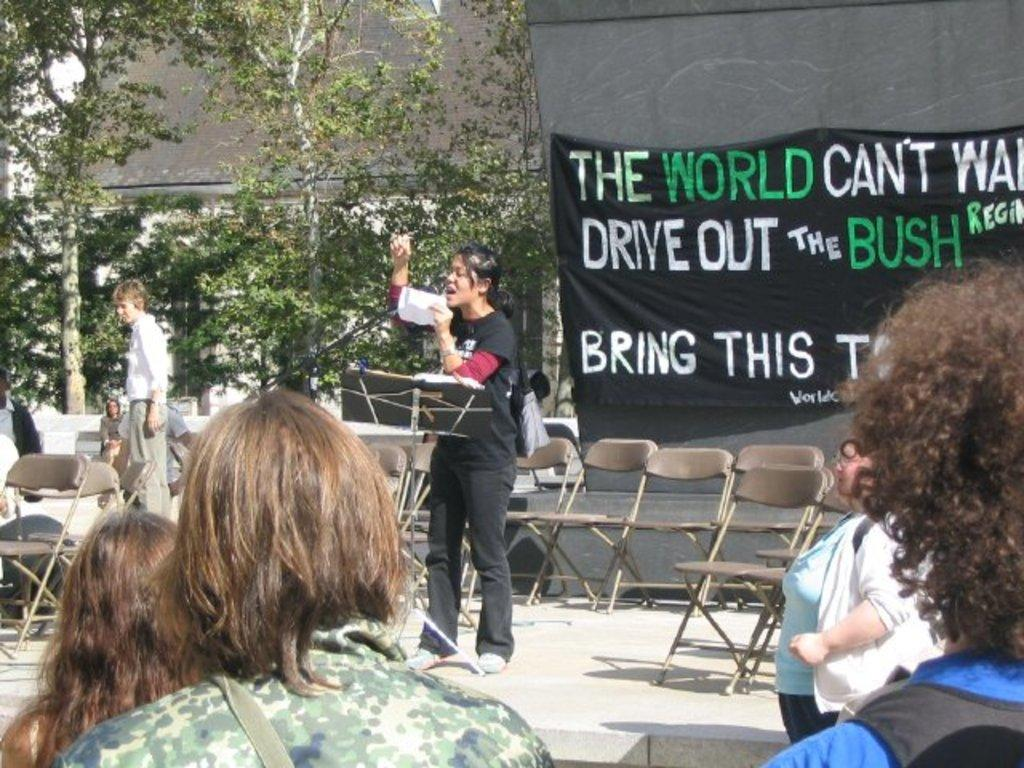How many people are in the image? There are people in the image, but the exact number is not specified. What type of furniture is present in the image? There are chairs in the image. What can be seen hanging in the image? There is a banner in the image. What type of natural elements are visible in the image? There are trees in the image. What type of structure is present in the image? There is a wall in the image. What objects are present in the image? There are objects in the image, but their specific nature is not specified. What is one person doing in the image? One person is holding a paper. What information is displayed on the banner? Something is written on the banner. What type of beef is being served at the event in the image? There is no mention of beef or any food in the image. What type of net is being used by the people in the image? There is no net present in the image. 